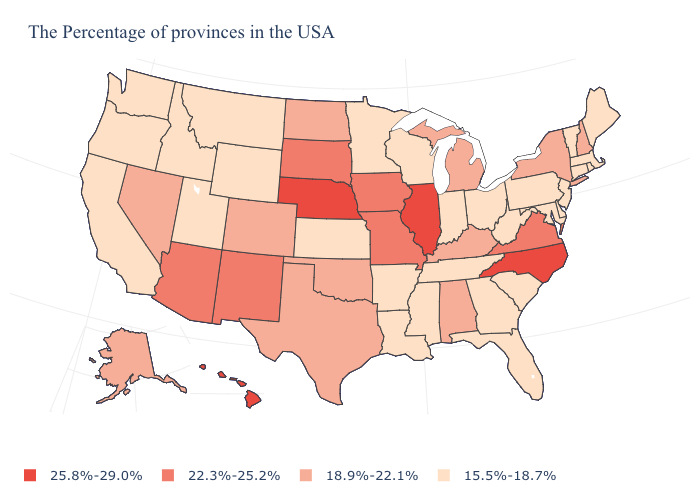What is the highest value in the West ?
Write a very short answer. 25.8%-29.0%. Name the states that have a value in the range 18.9%-22.1%?
Give a very brief answer. New Hampshire, New York, Michigan, Kentucky, Alabama, Oklahoma, Texas, North Dakota, Colorado, Nevada, Alaska. Does Maryland have a lower value than New York?
Be succinct. Yes. What is the value of Washington?
Be succinct. 15.5%-18.7%. Which states hav the highest value in the MidWest?
Answer briefly. Illinois, Nebraska. What is the lowest value in the West?
Give a very brief answer. 15.5%-18.7%. Among the states that border North Carolina , does South Carolina have the highest value?
Short answer required. No. Which states have the highest value in the USA?
Concise answer only. North Carolina, Illinois, Nebraska, Hawaii. Name the states that have a value in the range 25.8%-29.0%?
Short answer required. North Carolina, Illinois, Nebraska, Hawaii. Name the states that have a value in the range 22.3%-25.2%?
Be succinct. Virginia, Missouri, Iowa, South Dakota, New Mexico, Arizona. Which states hav the highest value in the MidWest?
Keep it brief. Illinois, Nebraska. Among the states that border Indiana , does Illinois have the highest value?
Give a very brief answer. Yes. What is the value of Wisconsin?
Keep it brief. 15.5%-18.7%. Does Montana have a higher value than Arizona?
Keep it brief. No. Among the states that border Wisconsin , which have the highest value?
Write a very short answer. Illinois. 